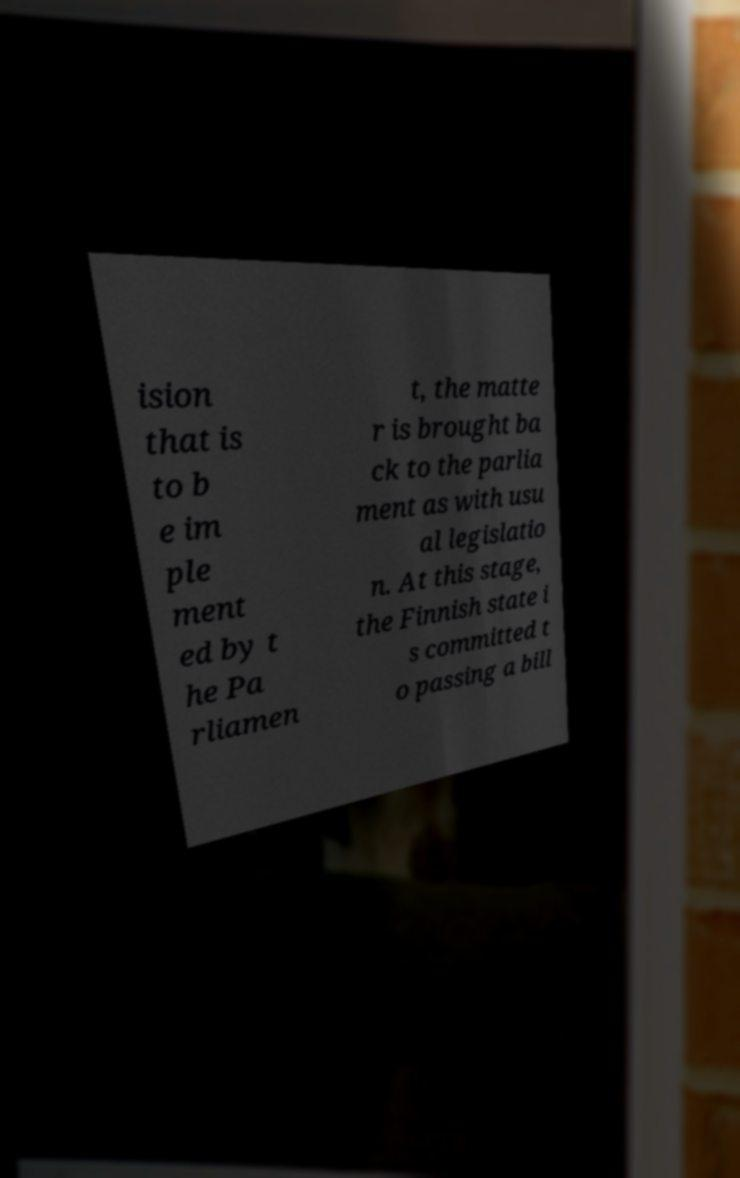For documentation purposes, I need the text within this image transcribed. Could you provide that? ision that is to b e im ple ment ed by t he Pa rliamen t, the matte r is brought ba ck to the parlia ment as with usu al legislatio n. At this stage, the Finnish state i s committed t o passing a bill 